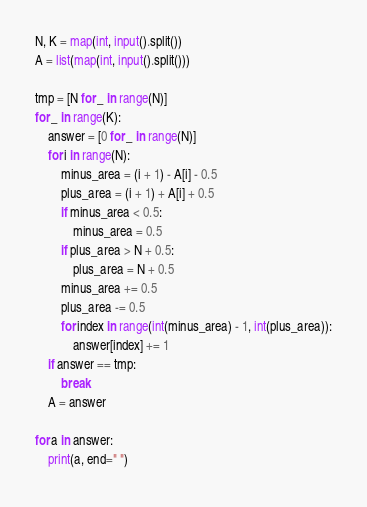Convert code to text. <code><loc_0><loc_0><loc_500><loc_500><_Python_>N, K = map(int, input().split())
A = list(map(int, input().split()))

tmp = [N for _ in range(N)]
for _ in range(K):
    answer = [0 for _ in range(N)]
    for i in range(N):
        minus_area = (i + 1) - A[i] - 0.5
        plus_area = (i + 1) + A[i] + 0.5
        if minus_area < 0.5:
            minus_area = 0.5
        if plus_area > N + 0.5:
            plus_area = N + 0.5
        minus_area += 0.5
        plus_area -= 0.5
        for index in range(int(minus_area) - 1, int(plus_area)):
            answer[index] += 1
    if answer == tmp:
        break
    A = answer

for a in answer:
    print(a, end=" ")</code> 